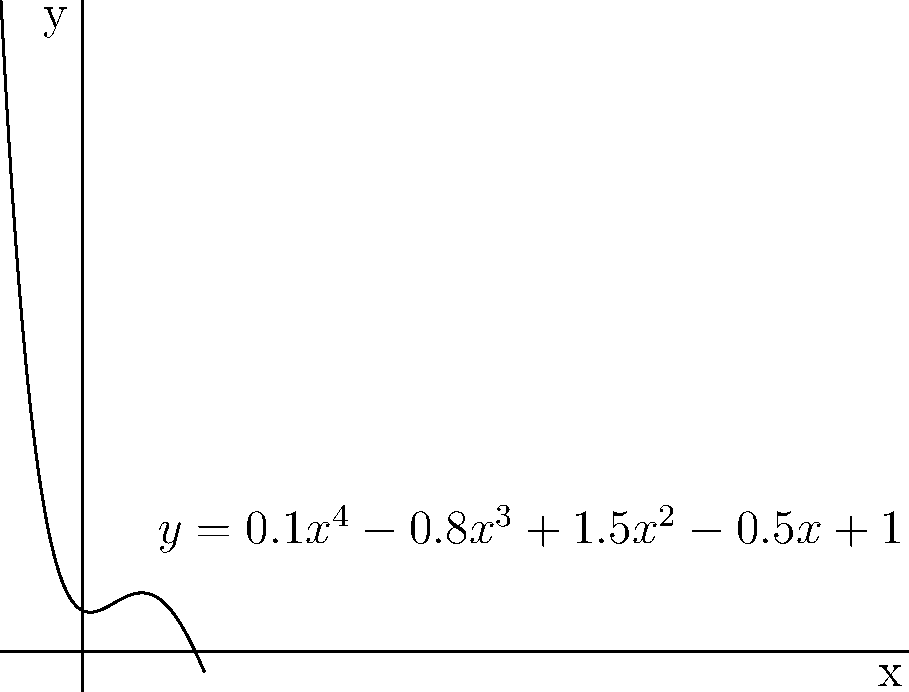In the development of a polynomial filter for noise reduction in radiological images, you've derived the following function to model the filter's response:

$y = 0.1x^4 - 0.8x^3 + 1.5x^2 - 0.5x + 1$

To optimize the filter's performance, you need to find the local minimum of this function. What is the x-coordinate of this local minimum? To find the local minimum of the given polynomial function, we need to follow these steps:

1) First, we need to find the derivative of the function:
   $f'(x) = 0.4x^3 - 2.4x^2 + 3x - 0.5$

2) Set the derivative equal to zero to find critical points:
   $0.4x^3 - 2.4x^2 + 3x - 0.5 = 0$

3) This is a cubic equation. We can solve it using the cubic formula or numerical methods. Using a numerical solver, we find the roots are approximately:
   $x ≈ -0.3858$, $x ≈ 1.3858$, and $x ≈ 5$

4) To determine which of these is a local minimum, we can either:
   a) Check the second derivative at each point
   b) Evaluate the function near each point
   c) Observe the graph

5) From the graph, we can see that the local minimum occurs at $x ≈ 1.3858$

6) To verify, we can check the function values:
   $f(-0.3858) ≈ 1.0718$
   $f(1.3858) ≈ 0.5205$
   $f(5) ≈ 38.5$

Indeed, $x ≈ 1.3858$ gives the lowest value among these critical points.

Therefore, the x-coordinate of the local minimum is approximately 1.3858.
Answer: 1.3858 